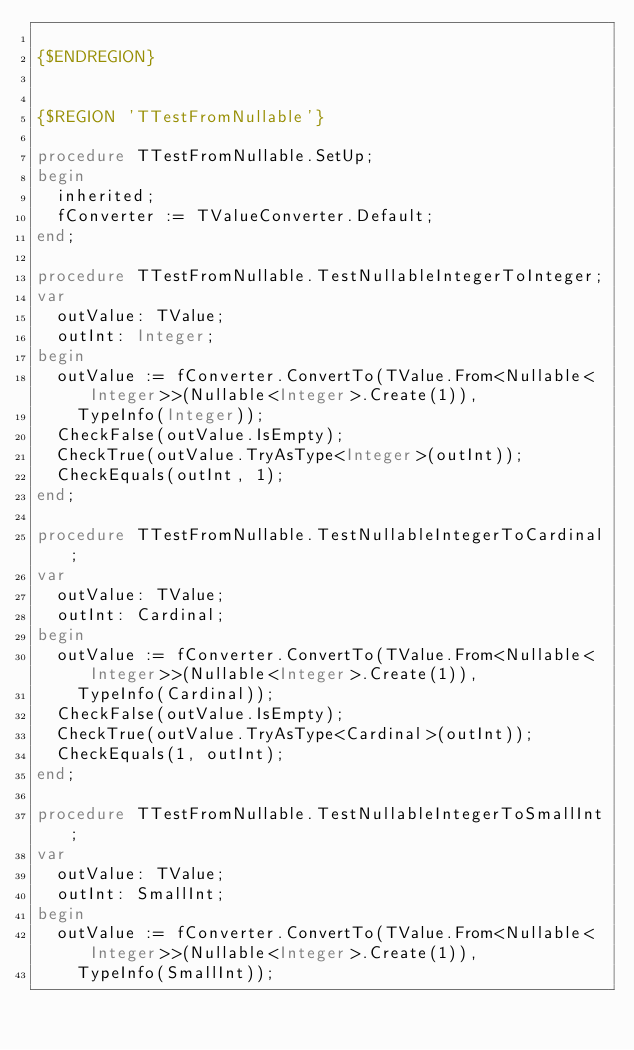<code> <loc_0><loc_0><loc_500><loc_500><_Pascal_>
{$ENDREGION}


{$REGION 'TTestFromNullable'}

procedure TTestFromNullable.SetUp;
begin
  inherited;
  fConverter := TValueConverter.Default;
end;

procedure TTestFromNullable.TestNullableIntegerToInteger;
var
  outValue: TValue;
  outInt: Integer;
begin
  outValue := fConverter.ConvertTo(TValue.From<Nullable<Integer>>(Nullable<Integer>.Create(1)),
    TypeInfo(Integer));
  CheckFalse(outValue.IsEmpty);
  CheckTrue(outValue.TryAsType<Integer>(outInt));
  CheckEquals(outInt, 1);
end;

procedure TTestFromNullable.TestNullableIntegerToCardinal;
var
  outValue: TValue;
  outInt: Cardinal;
begin
  outValue := fConverter.ConvertTo(TValue.From<Nullable<Integer>>(Nullable<Integer>.Create(1)),
    TypeInfo(Cardinal));
  CheckFalse(outValue.IsEmpty);
  CheckTrue(outValue.TryAsType<Cardinal>(outInt));
  CheckEquals(1, outInt);
end;

procedure TTestFromNullable.TestNullableIntegerToSmallInt;
var
  outValue: TValue;
  outInt: SmallInt;
begin
  outValue := fConverter.ConvertTo(TValue.From<Nullable<Integer>>(Nullable<Integer>.Create(1)),
    TypeInfo(SmallInt));</code> 